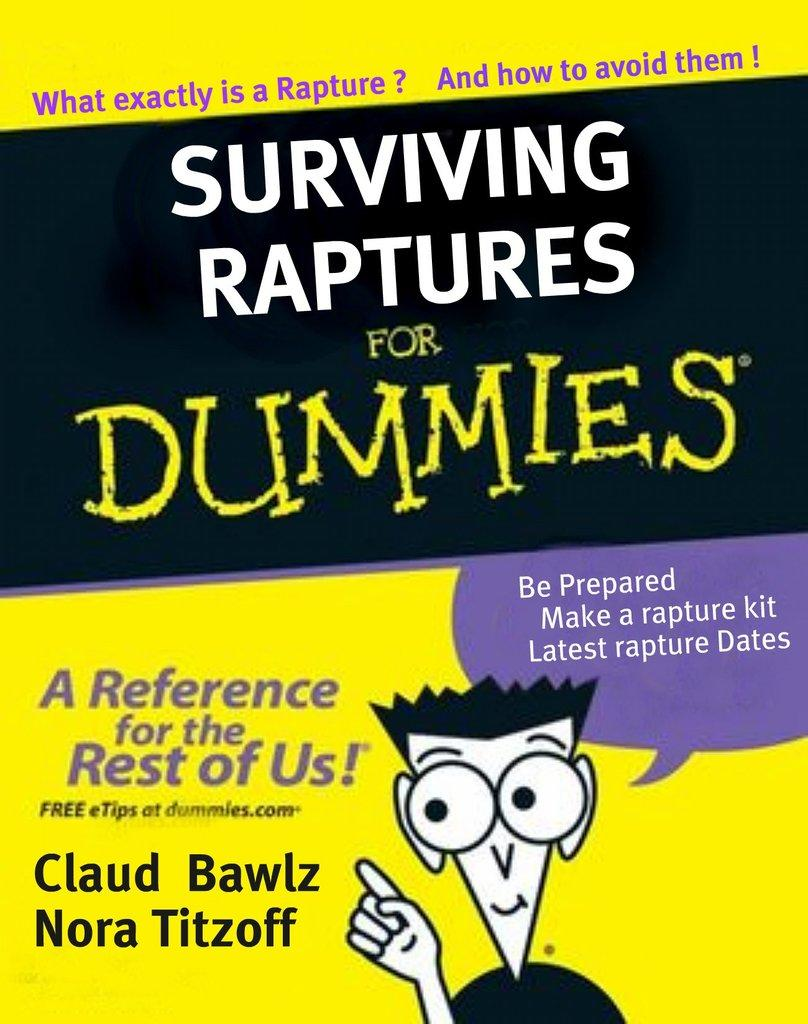<image>
Relay a brief, clear account of the picture shown. A copy of a book called Surviving Raptures for Dummies claims it can help you prepare for a rapture. 